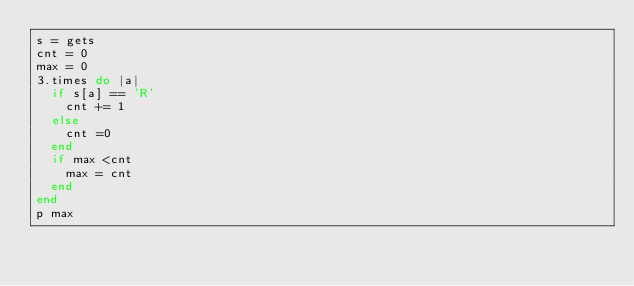<code> <loc_0><loc_0><loc_500><loc_500><_Ruby_>s = gets
cnt = 0
max = 0
3.times do |a|
  if s[a] == 'R'
    cnt += 1
  else
    cnt =0
  end
  if max <cnt
    max = cnt
  end
end
p max</code> 